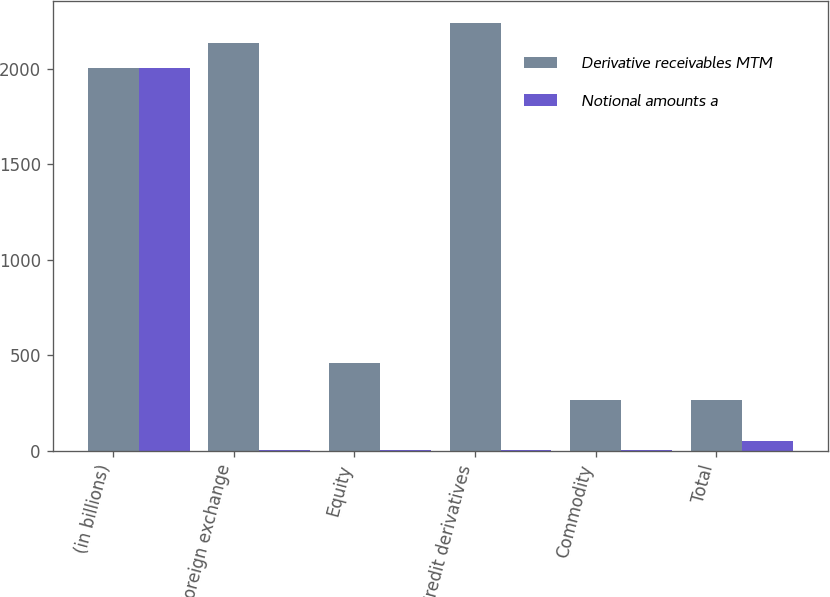Convert chart. <chart><loc_0><loc_0><loc_500><loc_500><stacked_bar_chart><ecel><fcel>(in billions)<fcel>Foreign exchange<fcel>Equity<fcel>Credit derivatives<fcel>Commodity<fcel>Total<nl><fcel>Derivative receivables MTM<fcel>2005<fcel>2136<fcel>458<fcel>2241<fcel>265<fcel>265<nl><fcel>Notional amounts a<fcel>2005<fcel>3<fcel>6<fcel>4<fcel>7<fcel>50<nl></chart> 